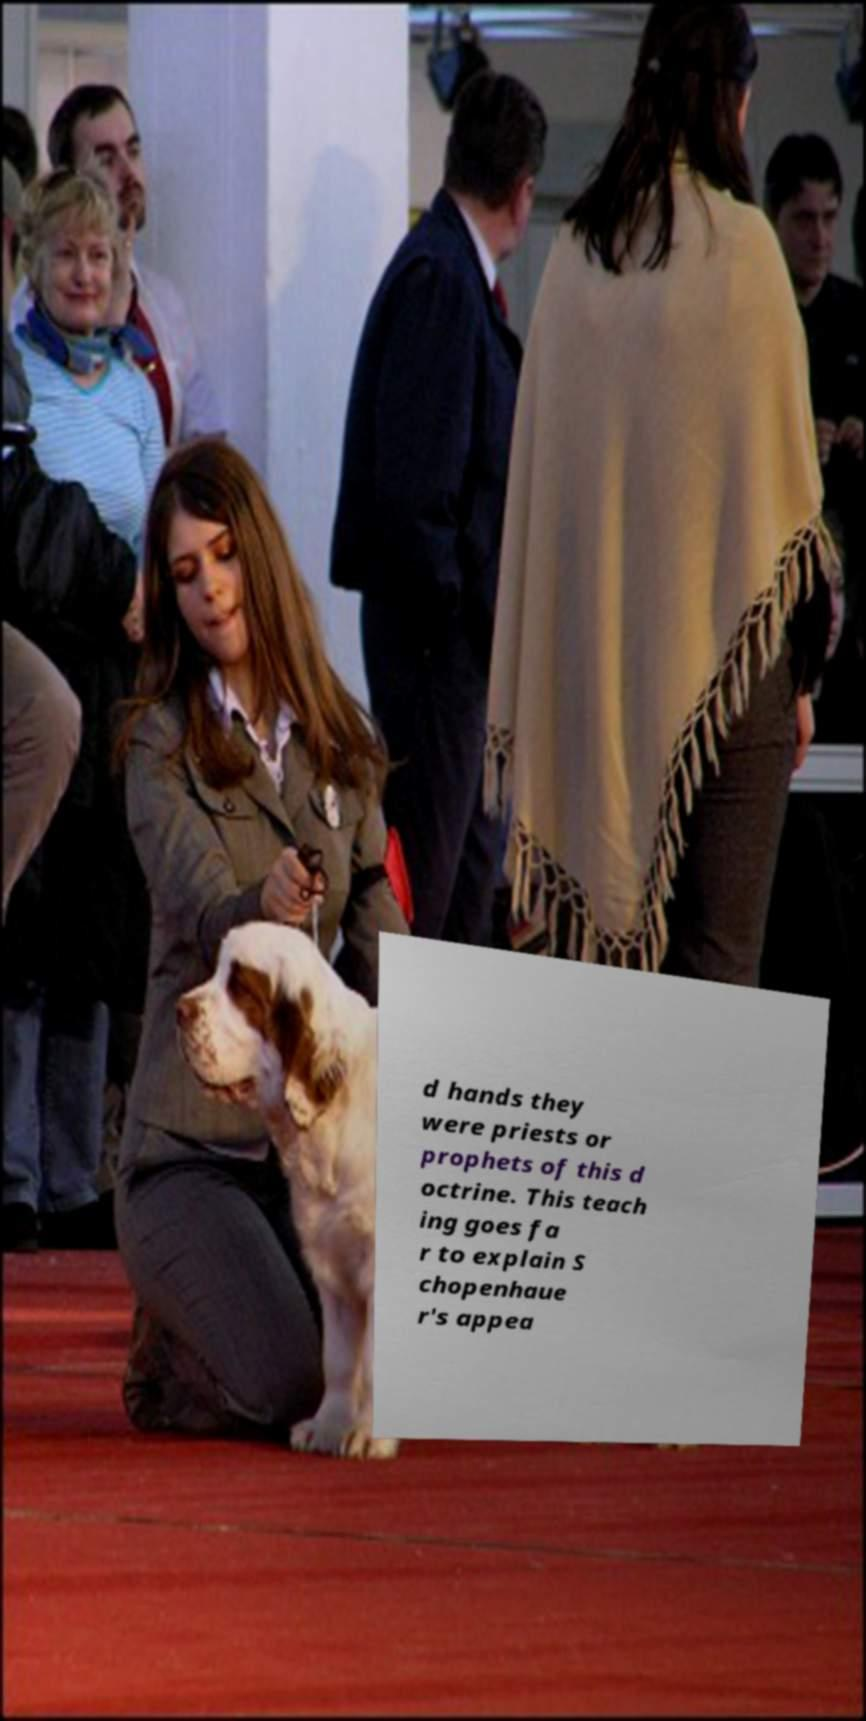Can you read and provide the text displayed in the image?This photo seems to have some interesting text. Can you extract and type it out for me? d hands they were priests or prophets of this d octrine. This teach ing goes fa r to explain S chopenhaue r's appea 